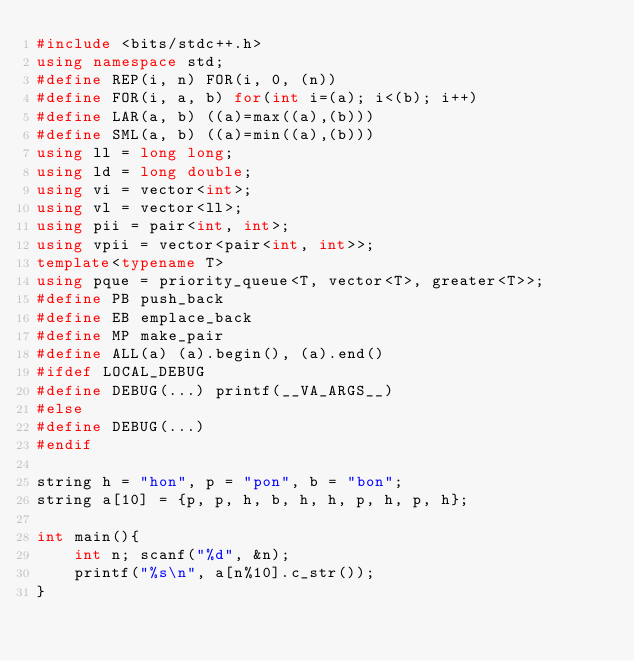<code> <loc_0><loc_0><loc_500><loc_500><_C++_>#include <bits/stdc++.h>
using namespace std;
#define REP(i, n) FOR(i, 0, (n))
#define FOR(i, a, b) for(int i=(a); i<(b); i++)
#define LAR(a, b) ((a)=max((a),(b)))
#define SML(a, b) ((a)=min((a),(b)))
using ll = long long;
using ld = long double;
using vi = vector<int>;
using vl = vector<ll>;
using pii = pair<int, int>;
using vpii = vector<pair<int, int>>;
template<typename T>
using pque = priority_queue<T, vector<T>, greater<T>>;
#define PB push_back
#define EB emplace_back
#define MP make_pair
#define ALL(a) (a).begin(), (a).end()
#ifdef LOCAL_DEBUG
#define DEBUG(...) printf(__VA_ARGS__)
#else
#define DEBUG(...)
#endif

string h = "hon", p = "pon", b = "bon";
string a[10] = {p, p, h, b, h, h, p, h, p, h};

int main(){
	int n; scanf("%d", &n);
	printf("%s\n", a[n%10].c_str());
}
</code> 